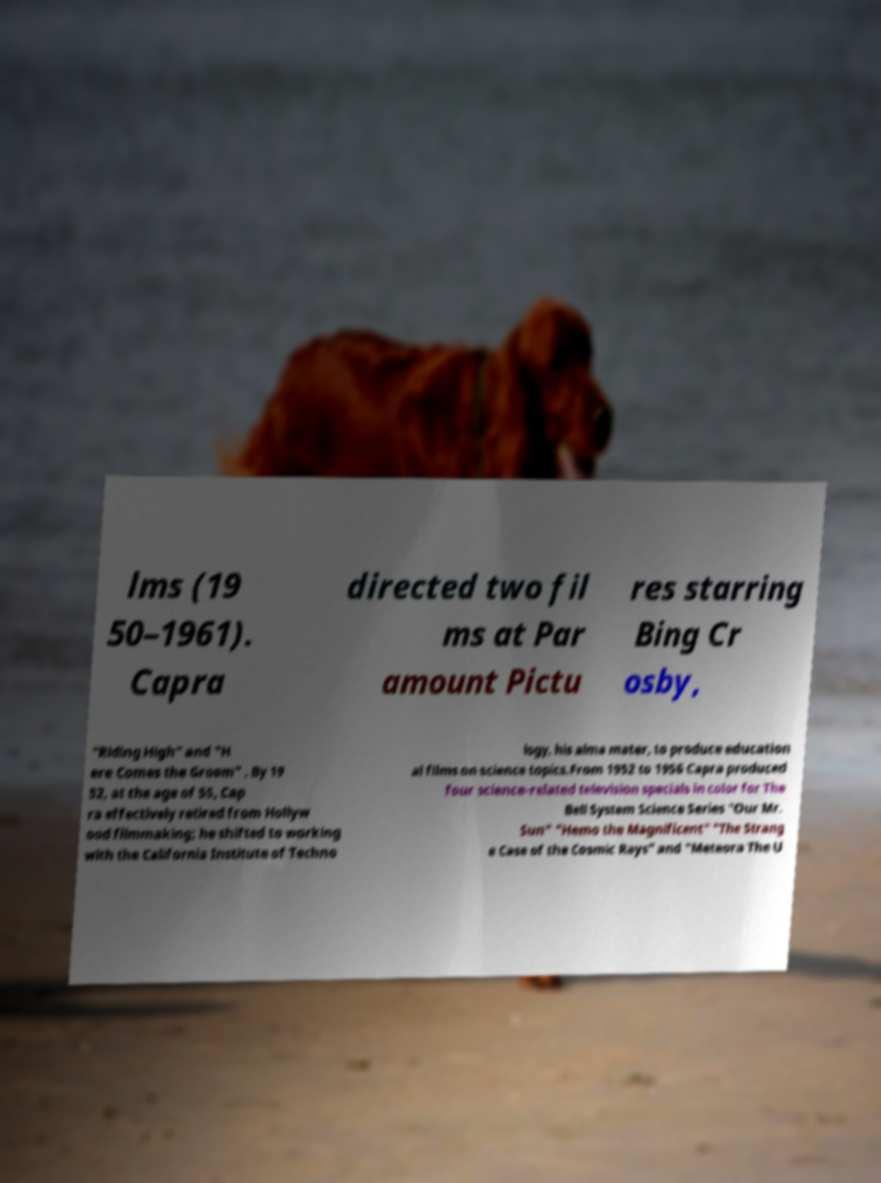Could you assist in decoding the text presented in this image and type it out clearly? lms (19 50–1961). Capra directed two fil ms at Par amount Pictu res starring Bing Cr osby, "Riding High" and "H ere Comes the Groom" . By 19 52, at the age of 55, Cap ra effectively retired from Hollyw ood filmmaking; he shifted to working with the California Institute of Techno logy, his alma mater, to produce education al films on science topics.From 1952 to 1956 Capra produced four science-related television specials in color for The Bell System Science Series "Our Mr. Sun" "Hemo the Magnificent" "The Strang e Case of the Cosmic Rays" and "Meteora The U 